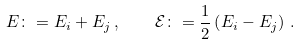Convert formula to latex. <formula><loc_0><loc_0><loc_500><loc_500>E \colon = E _ { i } + E _ { j } \, , \quad \mathcal { E } \colon = \frac { 1 } { 2 } \left ( E _ { i } - E _ { j } \right ) \, .</formula> 